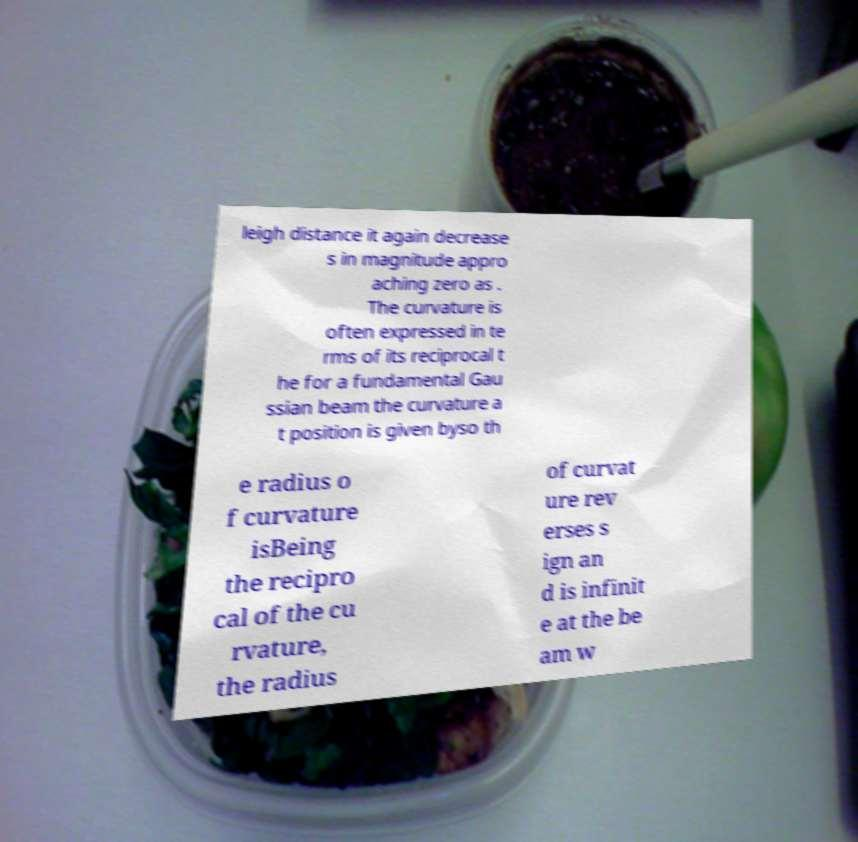Please read and relay the text visible in this image. What does it say? leigh distance it again decrease s in magnitude appro aching zero as . The curvature is often expressed in te rms of its reciprocal t he for a fundamental Gau ssian beam the curvature a t position is given byso th e radius o f curvature isBeing the recipro cal of the cu rvature, the radius of curvat ure rev erses s ign an d is infinit e at the be am w 